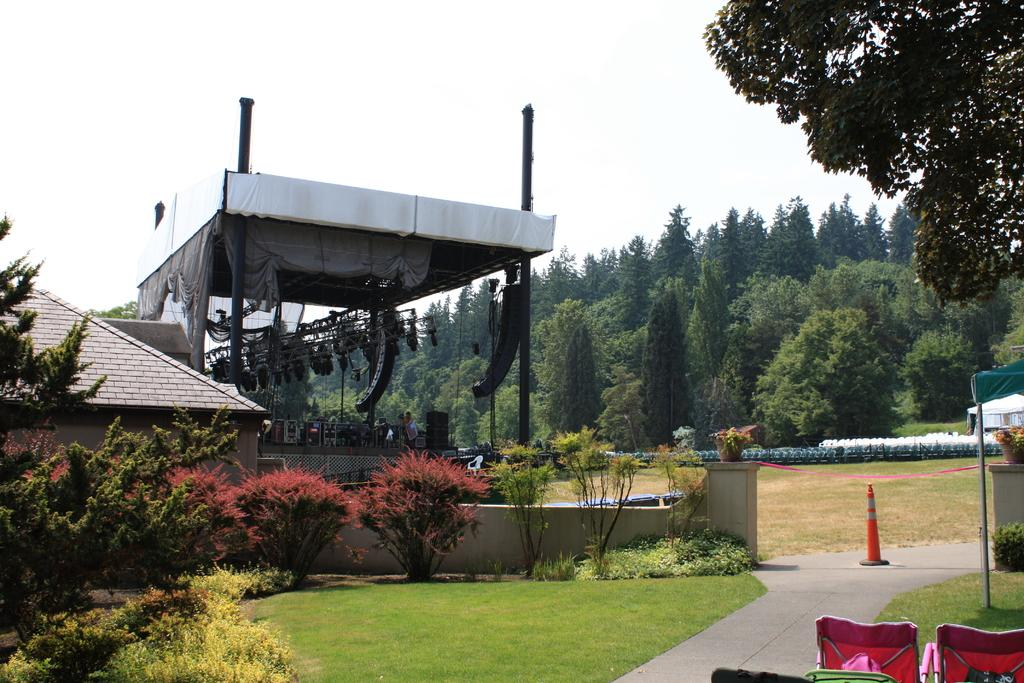What type of surface is visible in the image? There is a grass surface in the image. What type of vegetation can be seen in the image? There are plants and trees in the image. What type of furniture is present in the image? There are chairs in the image. What type of structure is visible in the image? There is a roof in the image. What is located under the roof in the image? There are objects under the roof in the image. What type of soup is being served in the image? There is no soup present in the image. What type of discovery is being made in the image? There is no discovery being made in the image. 